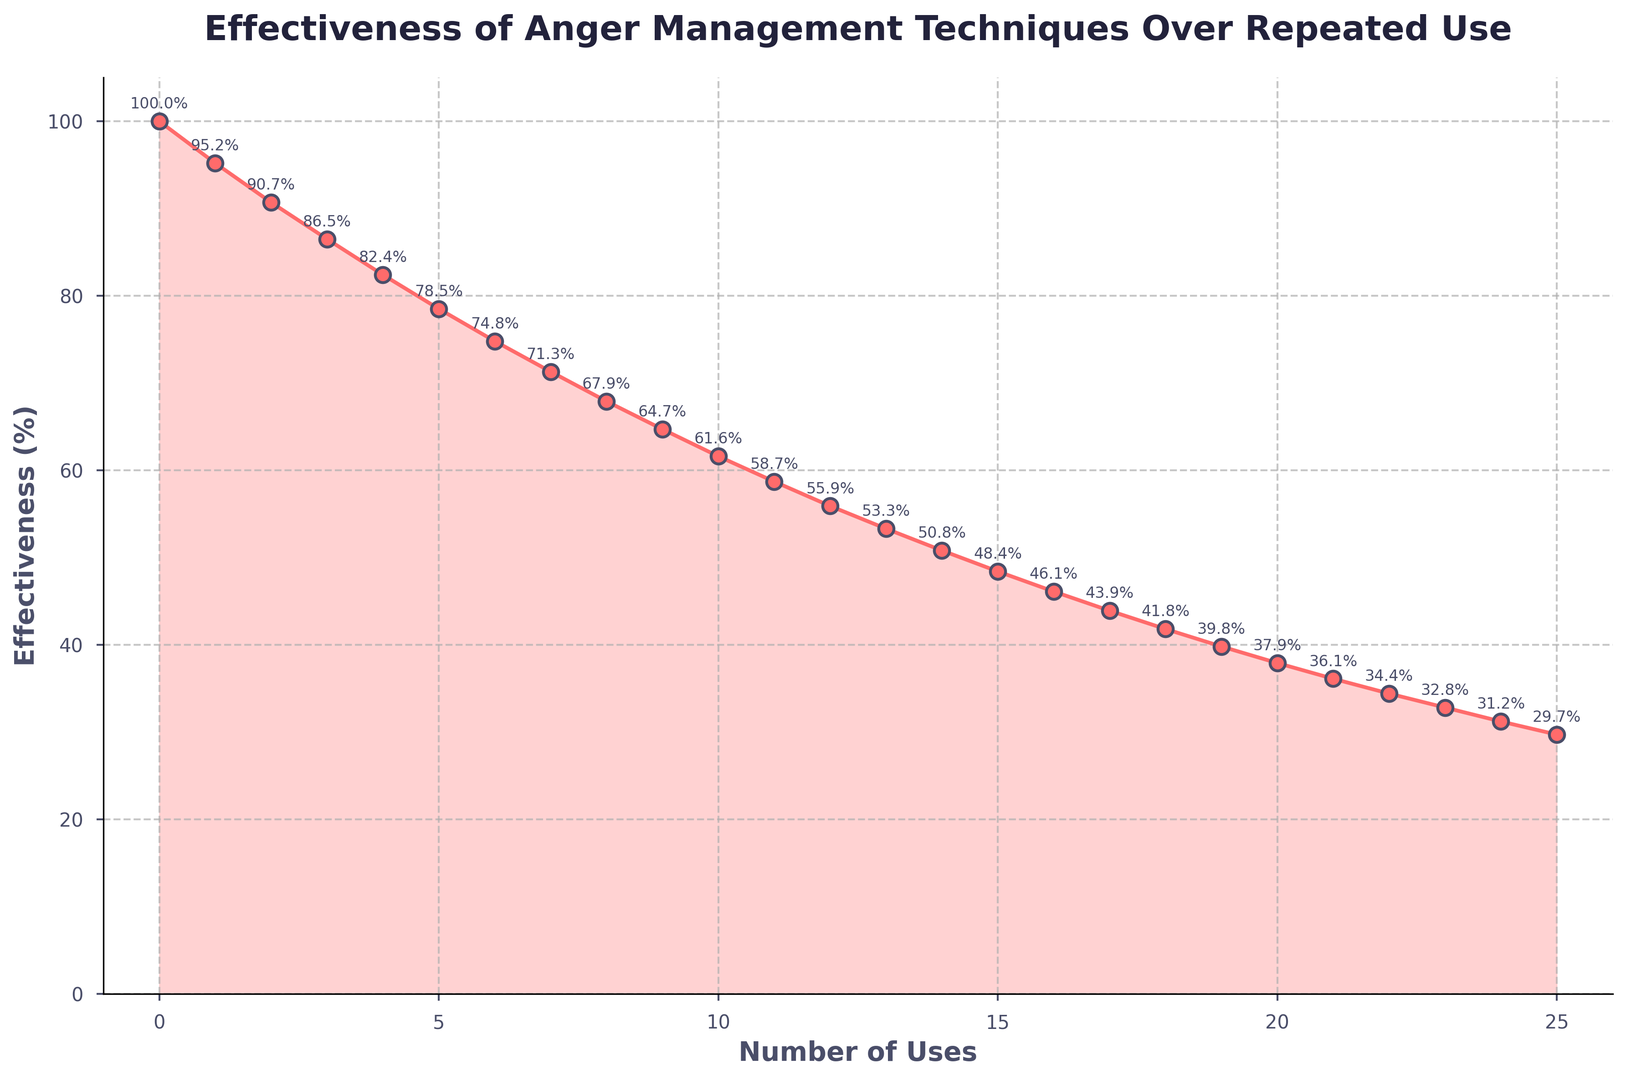What's the effectiveness of anger management techniques after 10 uses? To find the effectiveness after 10 uses, refer to the "Usage" axis at '10' and find the corresponding value on the "Effectiveness" axis. The plot shows that the effectiveness is 61.6%.
Answer: 61.6% After how many uses does the effectiveness drop below 50%? To determine when the effectiveness drops below 50%, refer to the "Usage" axis and follow the points until the effectiveness values are less than 50%. The plot indicates this happens between 14 and 15 uses.
Answer: 15 uses How much does the effectiveness decrease from the first use to the fifth use? Identify the effectiveness at the first use (100%) and at the fifth use (78.5%). Subtract the latter from the former: 100% - 78.5% = 21.5%.
Answer: 21.5% Is the decline in effectiveness consistent over repeated uses? Check the plot's trend line and observe the relative steepness between points. The plot displays a smooth exponential decay, indicating a consistent decline in effectiveness.
Answer: Yes What is the difference in effectiveness between the 8th and 12th uses? Find the effectiveness at the 8th use (67.9%) and at the 12th use (55.9%). Calculate the difference: 67.9% - 55.9% = 12.0%.
Answer: 12.0% Which usage interval shows the greatest drop in effectiveness? Compare the changes in effectiveness between each consecutive usage interval. The largest drop is between the first and second uses: 100% - 95.2% = 4.8%.
Answer: Between 0 and 1 uses Given the exponential decay nature, what is the effectiveness likely to be at use 26? Extrapolate the trend to the 26th use. Since the mathematical trend follows an exponential decay, the effectiveness is projected to continue decreasing but approach closer to 0%.
Answer: Close to 0% What does the shaded area under the curve represent? The shaded area under the curve visually indicates the cumulative effectiveness of the anger management techniques over repeated uses.
Answer: Cumulative effectiveness Does the plot suggest if anger management techniques become ineffective at a certain point? The plot shows the effectiveness decreasing over repeated uses but not fully reaching 0%. It suggests diminishing returns but does not indicate complete ineffectiveness within the given range.
Answer: No 